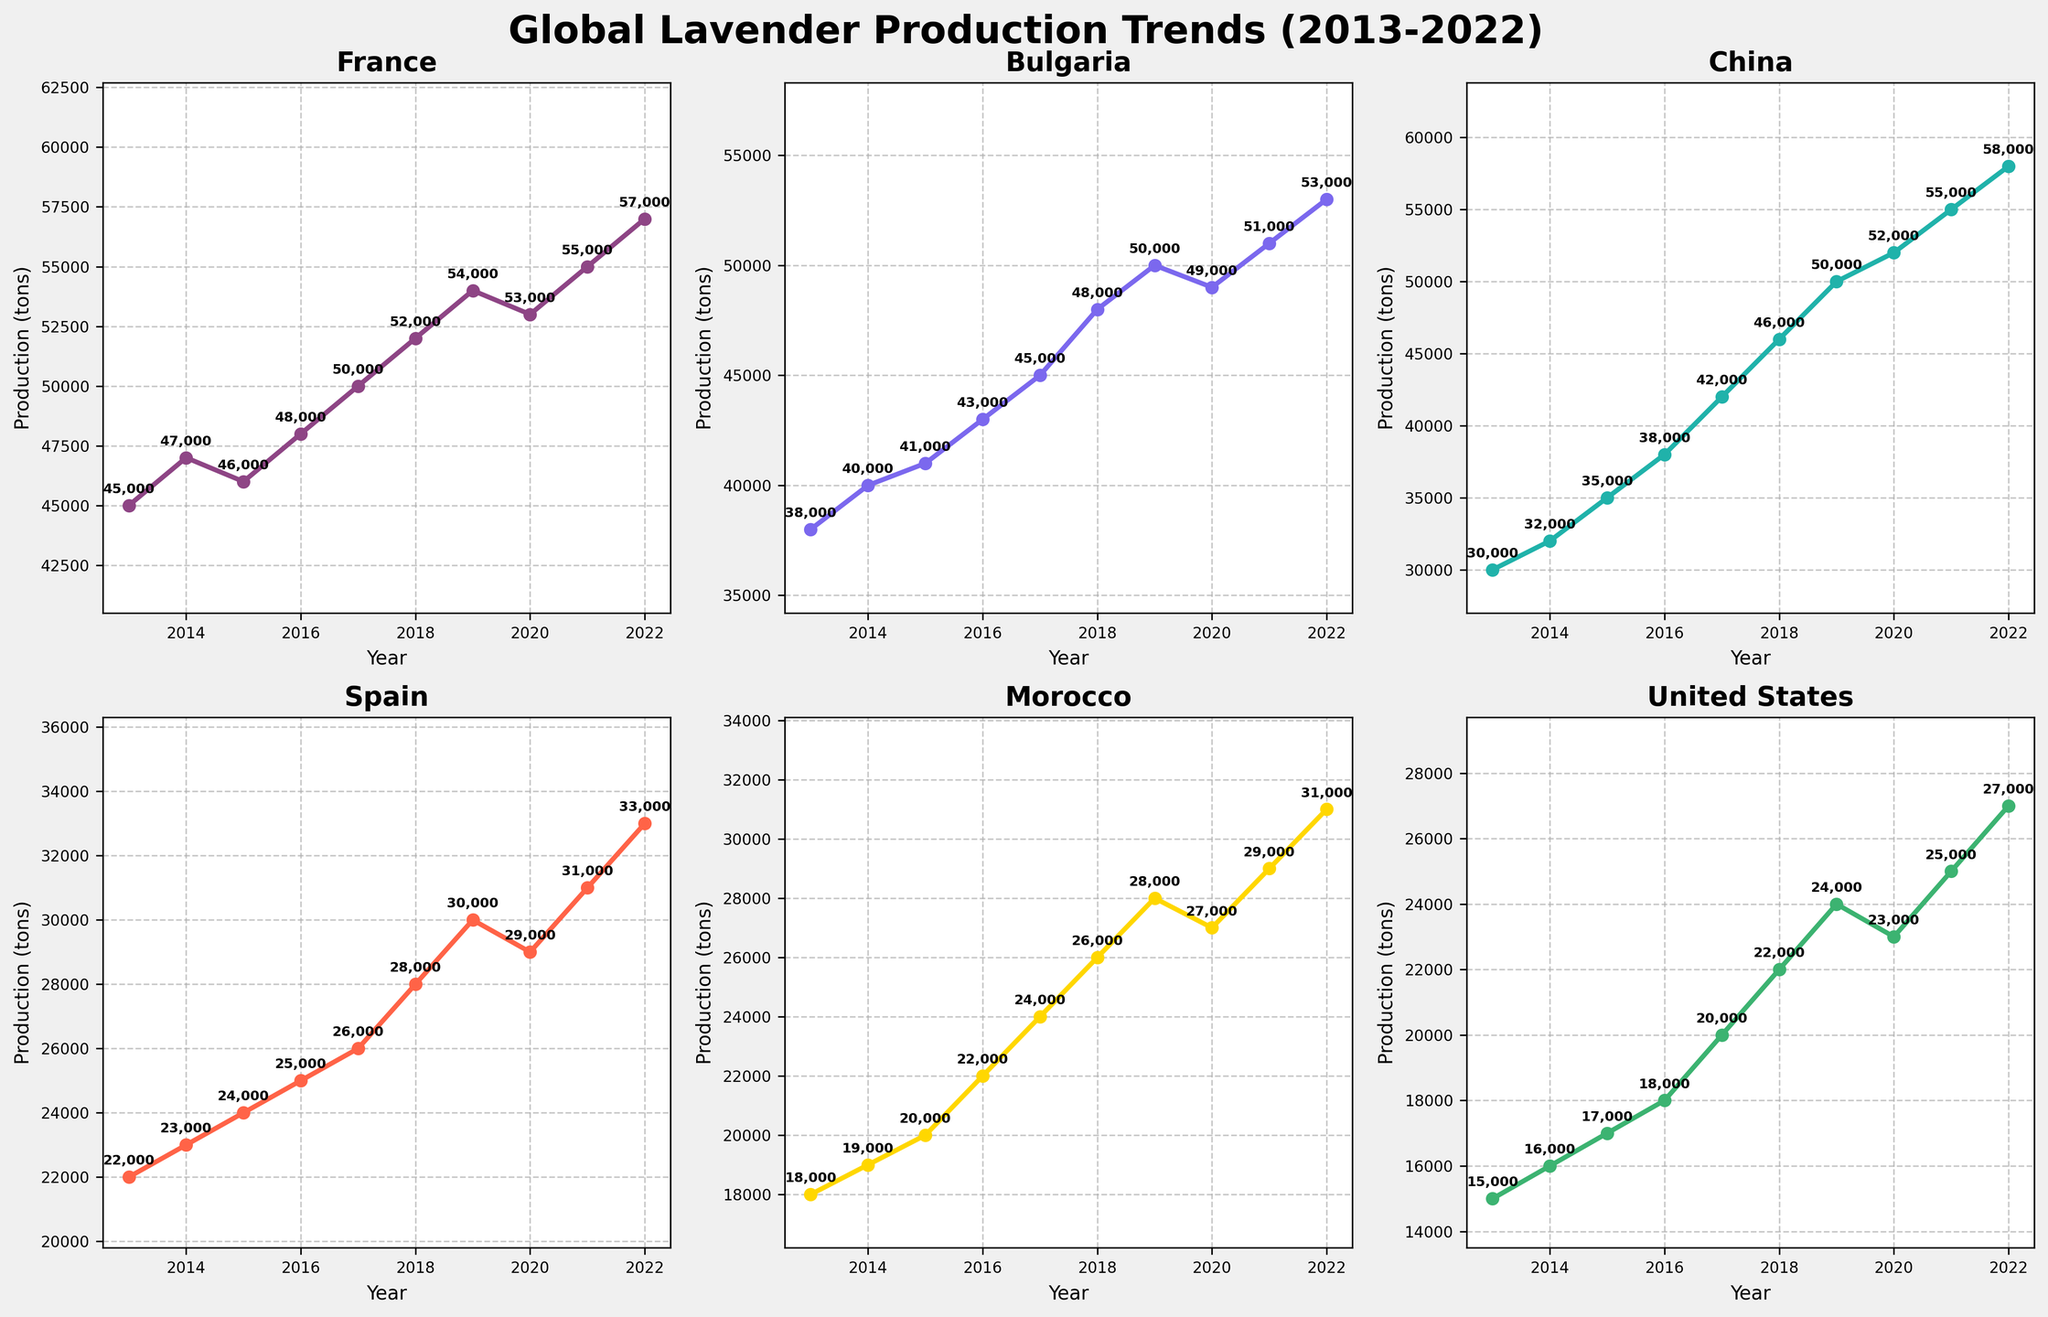Which country had the highest lavender production in 2022? By looking at the subplots for the year 2022, we see that China had the highest production among all countries.
Answer: China How did the lavender production in France change from 2019 to 2020? In the France subplot, the production decreased from 54,000 tons in 2019 to 53,000 tons in 2020, indicating a decrease of 1,000 tons.
Answer: Decreased by 1,000 tons What was the average lavender production for Spain from 2018 to 2022? The sum of the production for Spain from 2018 to 2022 is 28,000 + 30,000 + 29,000 + 31,000 + 33,000 = 151,000. There are 5 years, so the average is 151,000 / 5 = 30,200 tons.
Answer: 30,200 tons Which country showed the most consistent increase in lavender production from 2013 to 2022? By analyzing the subplots, Bulgaria showed a steady and consistent increase in lavender production every year from 2013 to 2022.
Answer: Bulgaria In 2016, how much more lavender did France produce compared to Bulgaria? In 2016, the production for France was 48,000 tons and for Bulgaria, it was 43,000 tons. The difference is 48,000 - 43,000 = 5,000 tons.
Answer: 5,000 tons Which country showed the largest fluctuation in lavender production over the years? By comparing the plots, China had significant changes in production, especially between 2015 to 2022, showing increases and decreases which reflect fluctuations.
Answer: China From 2017 to 2022, which country had a higher average lavender production: Morocco or the United States? Morocco's production from 2017-2022 was 24,000 + 26,000 + 28,000 + 27,000 + 29,000 + 31,000 = 165,000 tons, averaging 165,000 / 6 = 27,500 tons. The United States' production was 20,000 + 22,000 + 24,000 + 23,000 + 25,000 + 27,000 = 141,000 tons, averaging 141,000 / 6 = 23,500 tons.
Answer: Morocco Identify the year when Bulgaria and China produced the same amount of lavender. In the year 2019, both Bulgaria and China had a production of 50,000 tons, as shown in their respective subplots.
Answer: 2019 Which country had the highest increase in lavender production from 2013 to 2022? Comparing the initial and final years, China showed the highest increase. In 2013, China produced 30,000 tons, and in 2022, it produced 58,000 tons, an increase of 28,000 tons; this increase is the largest compared to other countries.
Answer: China 